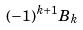Convert formula to latex. <formula><loc_0><loc_0><loc_500><loc_500>( - 1 ) ^ { k + 1 } B _ { k }</formula> 